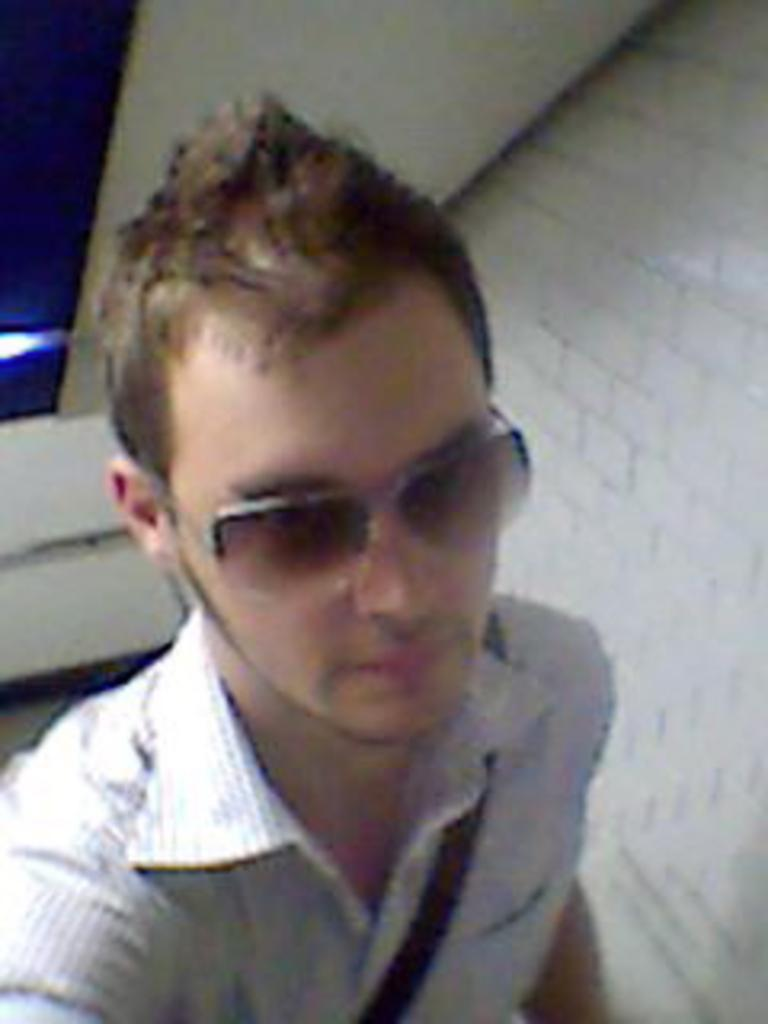What is present in the image? There is a man in the image. Can you describe the man's appearance? The man is wearing spectacles. What can be seen in the background of the image? There are walls visible in the background of the image. What type of coat is the man wearing in the image? The man is not wearing a coat in the image; he is wearing spectacles. What type of brake system can be seen on the man in the image? There is no brake system present in the image, as it features a man wearing spectacles and standing in front of walls. 